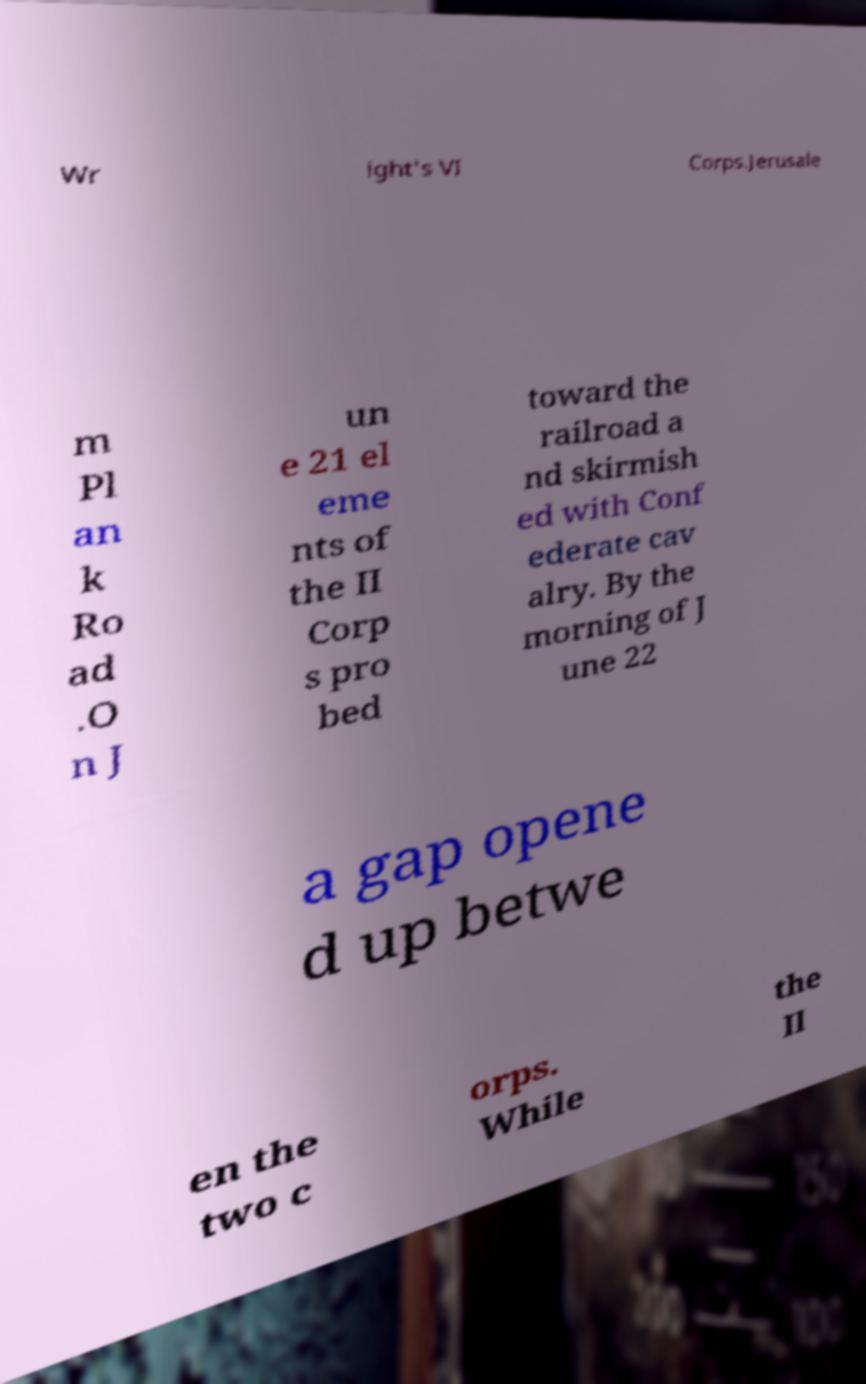Please identify and transcribe the text found in this image. Wr ight's VI Corps.Jerusale m Pl an k Ro ad .O n J un e 21 el eme nts of the II Corp s pro bed toward the railroad a nd skirmish ed with Conf ederate cav alry. By the morning of J une 22 a gap opene d up betwe en the two c orps. While the II 